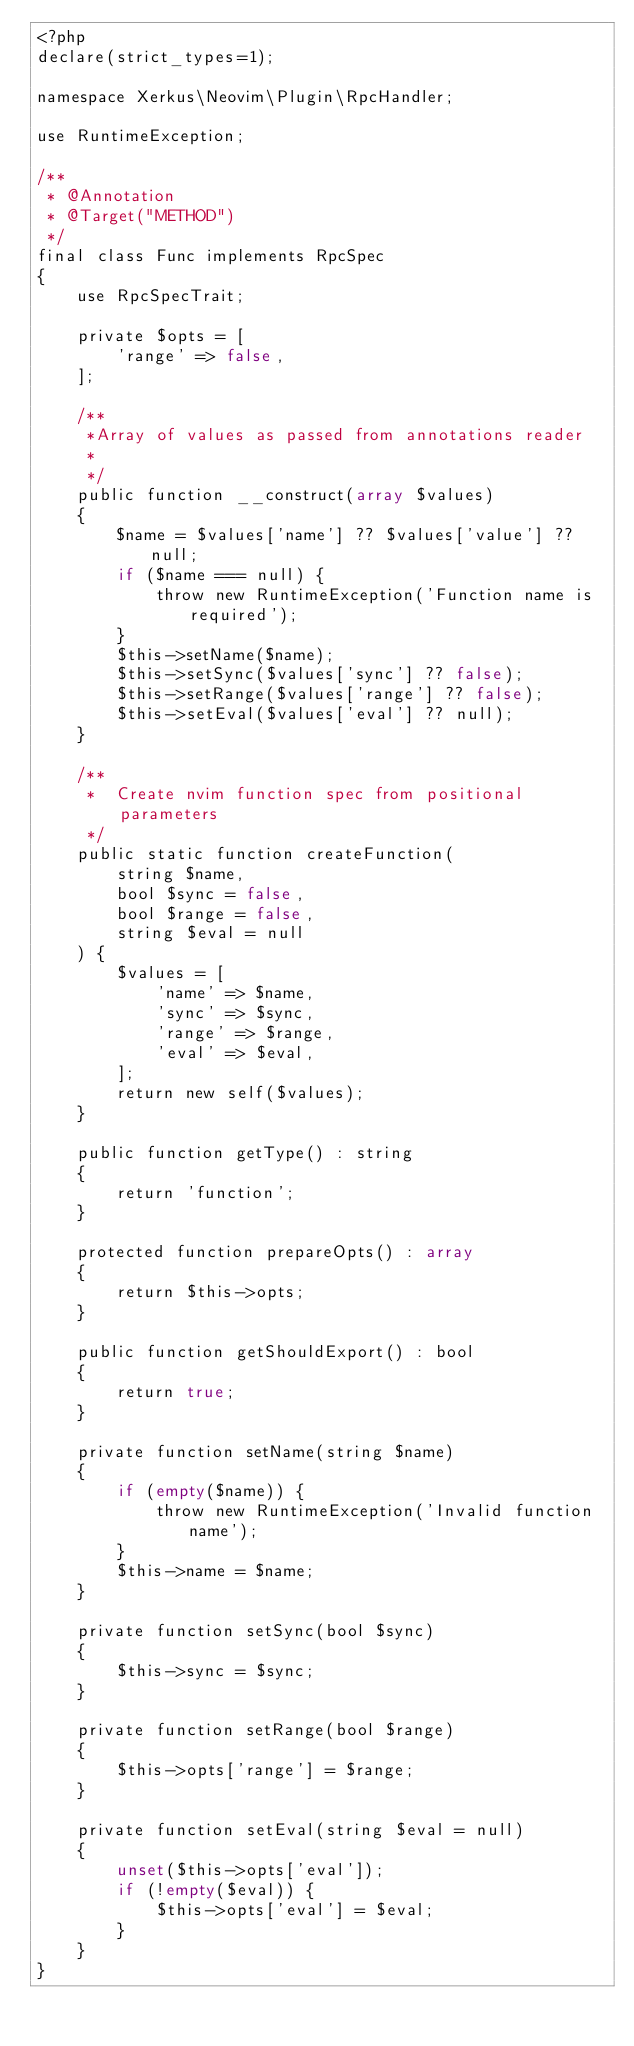Convert code to text. <code><loc_0><loc_0><loc_500><loc_500><_PHP_><?php
declare(strict_types=1);

namespace Xerkus\Neovim\Plugin\RpcHandler;

use RuntimeException;

/**
 * @Annotation
 * @Target("METHOD")
 */
final class Func implements RpcSpec
{
    use RpcSpecTrait;

    private $opts = [
        'range' => false,
    ];

    /**
     *Array of values as passed from annotations reader
     *
     */
    public function __construct(array $values)
    {
        $name = $values['name'] ?? $values['value'] ?? null;
        if ($name === null) {
            throw new RuntimeException('Function name is required');
        }
        $this->setName($name);
        $this->setSync($values['sync'] ?? false);
        $this->setRange($values['range'] ?? false);
        $this->setEval($values['eval'] ?? null);
    }

    /**
     *  Create nvim function spec from positional parameters
     */
    public static function createFunction(
        string $name,
        bool $sync = false,
        bool $range = false,
        string $eval = null
    ) {
        $values = [
            'name' => $name,
            'sync' => $sync,
            'range' => $range,
            'eval' => $eval,
        ];
        return new self($values);
    }

    public function getType() : string
    {
        return 'function';
    }

    protected function prepareOpts() : array
    {
        return $this->opts;
    }

    public function getShouldExport() : bool
    {
        return true;
    }

    private function setName(string $name)
    {
        if (empty($name)) {
            throw new RuntimeException('Invalid function name');
        }
        $this->name = $name;
    }

    private function setSync(bool $sync)
    {
        $this->sync = $sync;
    }

    private function setRange(bool $range)
    {
        $this->opts['range'] = $range;
    }

    private function setEval(string $eval = null)
    {
        unset($this->opts['eval']);
        if (!empty($eval)) {
            $this->opts['eval'] = $eval;
        }
    }
}
</code> 